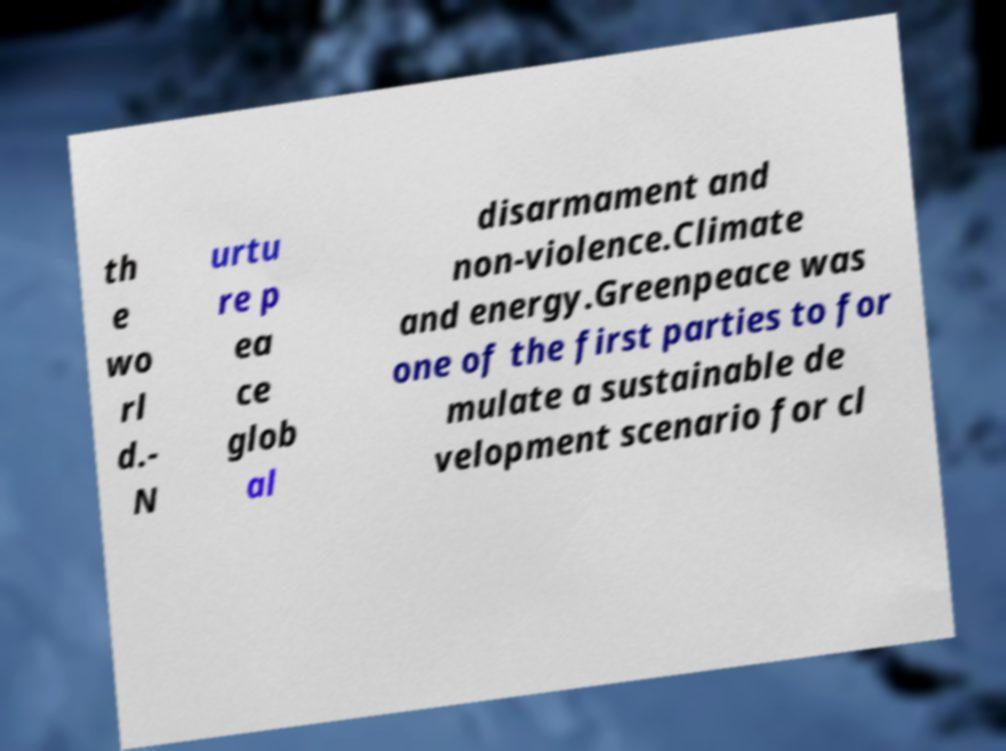What messages or text are displayed in this image? I need them in a readable, typed format. th e wo rl d.- N urtu re p ea ce glob al disarmament and non-violence.Climate and energy.Greenpeace was one of the first parties to for mulate a sustainable de velopment scenario for cl 